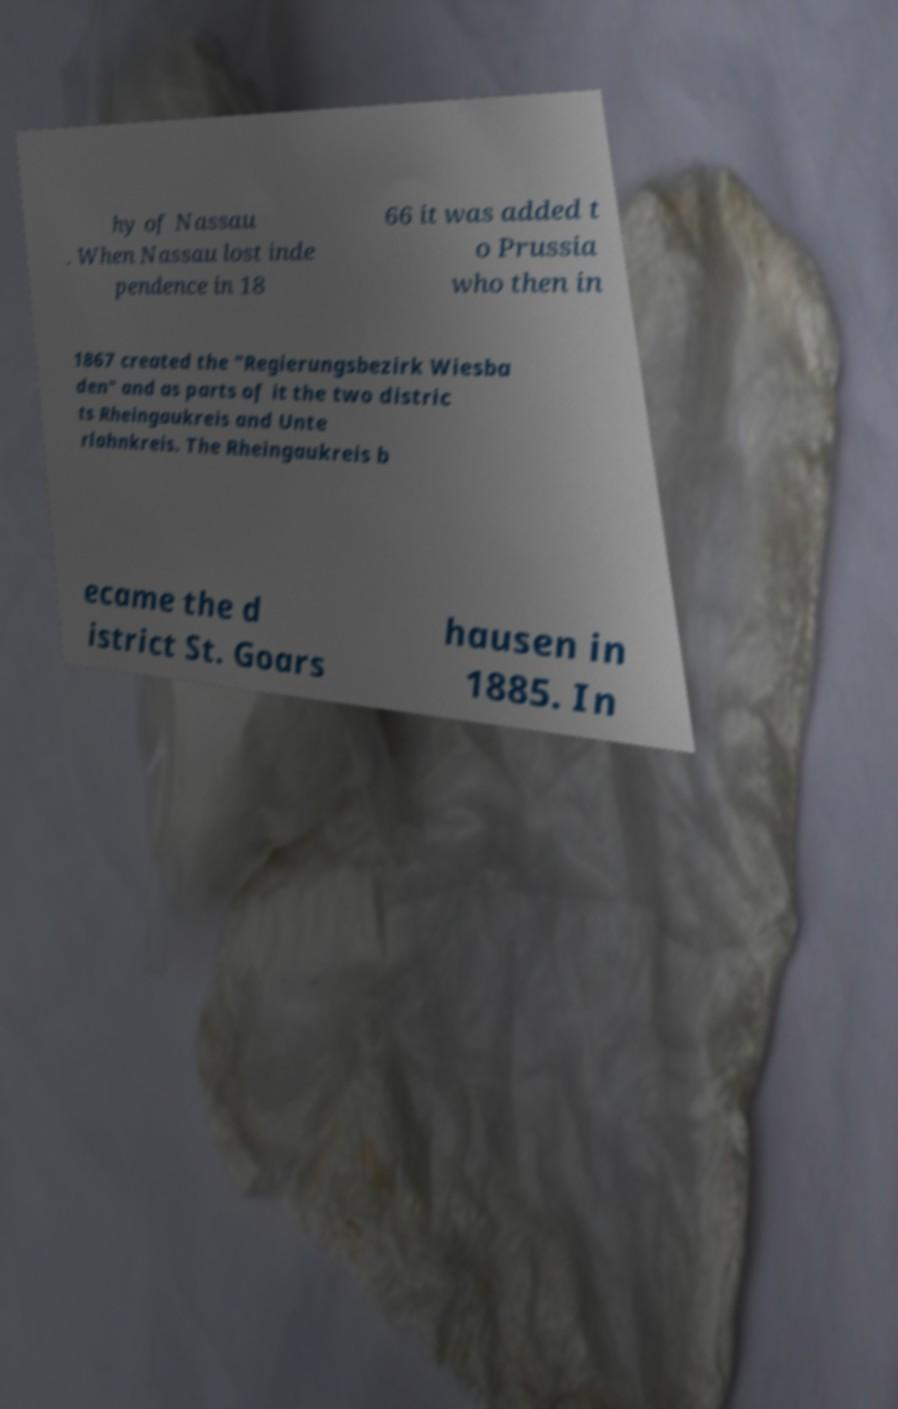For documentation purposes, I need the text within this image transcribed. Could you provide that? hy of Nassau . When Nassau lost inde pendence in 18 66 it was added t o Prussia who then in 1867 created the "Regierungsbezirk Wiesba den" and as parts of it the two distric ts Rheingaukreis and Unte rlahnkreis. The Rheingaukreis b ecame the d istrict St. Goars hausen in 1885. In 